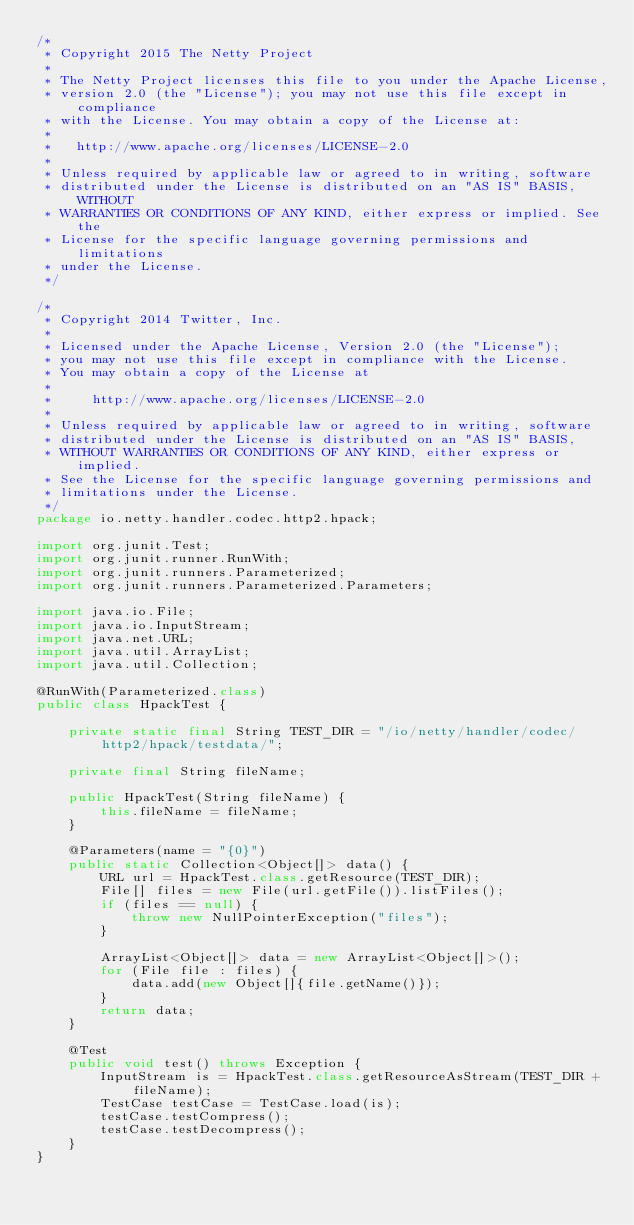<code> <loc_0><loc_0><loc_500><loc_500><_Java_>/*
 * Copyright 2015 The Netty Project
 *
 * The Netty Project licenses this file to you under the Apache License,
 * version 2.0 (the "License"); you may not use this file except in compliance
 * with the License. You may obtain a copy of the License at:
 *
 *   http://www.apache.org/licenses/LICENSE-2.0
 *
 * Unless required by applicable law or agreed to in writing, software
 * distributed under the License is distributed on an "AS IS" BASIS, WITHOUT
 * WARRANTIES OR CONDITIONS OF ANY KIND, either express or implied. See the
 * License for the specific language governing permissions and limitations
 * under the License.
 */

/*
 * Copyright 2014 Twitter, Inc.
 *
 * Licensed under the Apache License, Version 2.0 (the "License");
 * you may not use this file except in compliance with the License.
 * You may obtain a copy of the License at
 *
 *     http://www.apache.org/licenses/LICENSE-2.0
 *
 * Unless required by applicable law or agreed to in writing, software
 * distributed under the License is distributed on an "AS IS" BASIS,
 * WITHOUT WARRANTIES OR CONDITIONS OF ANY KIND, either express or implied.
 * See the License for the specific language governing permissions and
 * limitations under the License.
 */
package io.netty.handler.codec.http2.hpack;

import org.junit.Test;
import org.junit.runner.RunWith;
import org.junit.runners.Parameterized;
import org.junit.runners.Parameterized.Parameters;

import java.io.File;
import java.io.InputStream;
import java.net.URL;
import java.util.ArrayList;
import java.util.Collection;

@RunWith(Parameterized.class)
public class HpackTest {

    private static final String TEST_DIR = "/io/netty/handler/codec/http2/hpack/testdata/";

    private final String fileName;

    public HpackTest(String fileName) {
        this.fileName = fileName;
    }

    @Parameters(name = "{0}")
    public static Collection<Object[]> data() {
        URL url = HpackTest.class.getResource(TEST_DIR);
        File[] files = new File(url.getFile()).listFiles();
        if (files == null) {
            throw new NullPointerException("files");
        }

        ArrayList<Object[]> data = new ArrayList<Object[]>();
        for (File file : files) {
            data.add(new Object[]{file.getName()});
        }
        return data;
    }

    @Test
    public void test() throws Exception {
        InputStream is = HpackTest.class.getResourceAsStream(TEST_DIR + fileName);
        TestCase testCase = TestCase.load(is);
        testCase.testCompress();
        testCase.testDecompress();
    }
}
</code> 